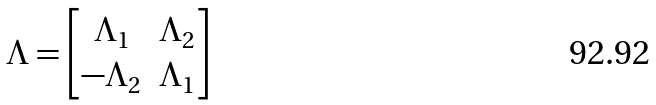<formula> <loc_0><loc_0><loc_500><loc_500>\Lambda = \begin{bmatrix} \Lambda _ { 1 } & \Lambda _ { 2 } \\ - \Lambda _ { 2 } & \Lambda _ { 1 } \end{bmatrix}</formula> 